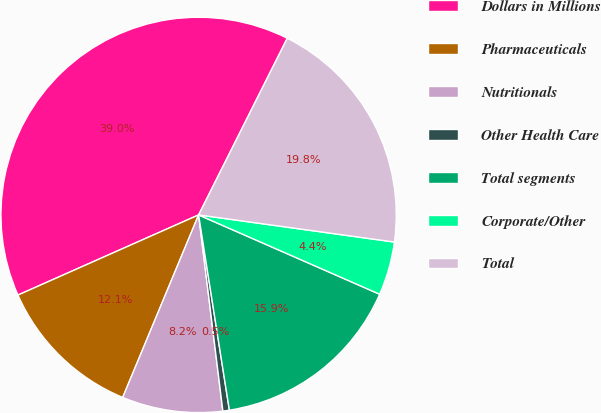Convert chart. <chart><loc_0><loc_0><loc_500><loc_500><pie_chart><fcel>Dollars in Millions<fcel>Pharmaceuticals<fcel>Nutritionals<fcel>Other Health Care<fcel>Total segments<fcel>Corporate/Other<fcel>Total<nl><fcel>39.05%<fcel>12.08%<fcel>8.23%<fcel>0.53%<fcel>15.94%<fcel>4.38%<fcel>19.79%<nl></chart> 